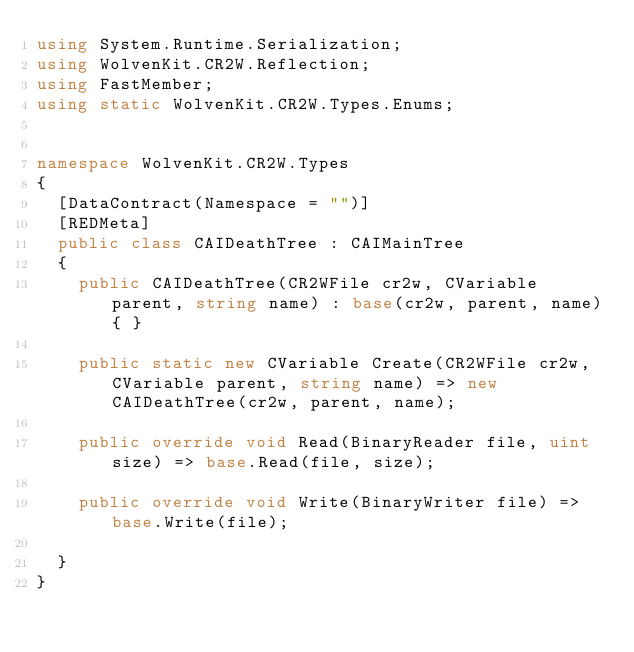Convert code to text. <code><loc_0><loc_0><loc_500><loc_500><_C#_>using System.Runtime.Serialization;
using WolvenKit.CR2W.Reflection;
using FastMember;
using static WolvenKit.CR2W.Types.Enums;


namespace WolvenKit.CR2W.Types
{
	[DataContract(Namespace = "")]
	[REDMeta]
	public class CAIDeathTree : CAIMainTree
	{
		public CAIDeathTree(CR2WFile cr2w, CVariable parent, string name) : base(cr2w, parent, name){ }

		public static new CVariable Create(CR2WFile cr2w, CVariable parent, string name) => new CAIDeathTree(cr2w, parent, name);

		public override void Read(BinaryReader file, uint size) => base.Read(file, size);

		public override void Write(BinaryWriter file) => base.Write(file);

	}
}</code> 